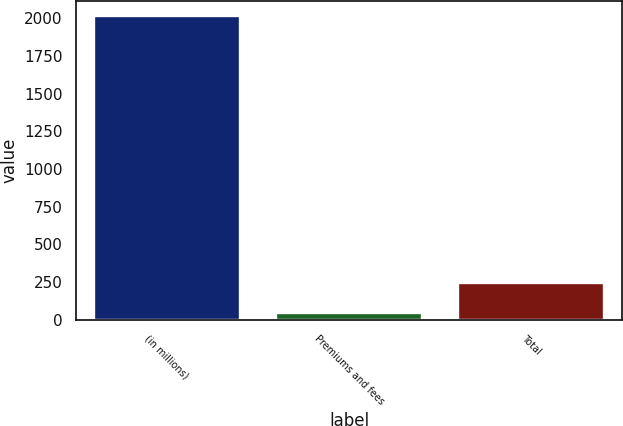Convert chart. <chart><loc_0><loc_0><loc_500><loc_500><bar_chart><fcel>(in millions)<fcel>Premiums and fees<fcel>Total<nl><fcel>2014<fcel>44<fcel>241<nl></chart> 